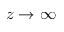<formula> <loc_0><loc_0><loc_500><loc_500>z \rightarrow \infty</formula> 